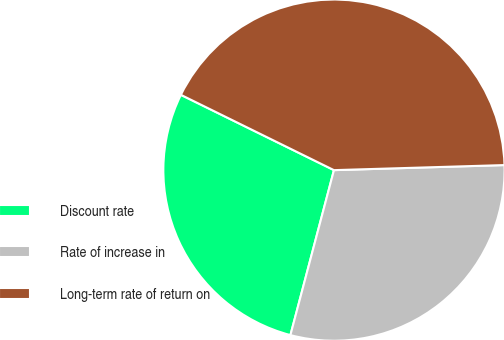Convert chart to OTSL. <chart><loc_0><loc_0><loc_500><loc_500><pie_chart><fcel>Discount rate<fcel>Rate of increase in<fcel>Long-term rate of return on<nl><fcel>28.17%<fcel>29.58%<fcel>42.25%<nl></chart> 